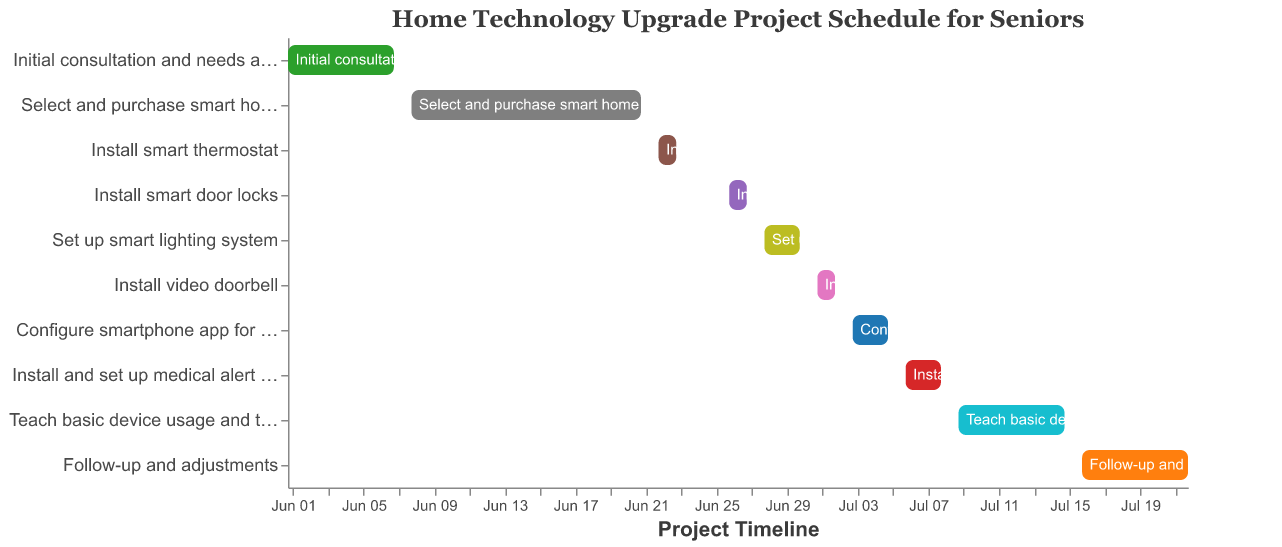What is the title of the Gantt Chart? The title of the chart is usually displayed prominently at the top. In this case, it reads "Home Technology Upgrade Project Schedule for Seniors."
Answer: Home Technology Upgrade Project Schedule for Seniors When does the project to "Install smart door locks" start and end? By looking at the "Install smart door locks" task, you can see the start and end dates mentioned as June 26 and June 27 respectively.
Answer: June 26 to June 27 How many days is the "Initial consultation and needs assessment" scheduled to last? To find the duration, subtract the start date (June 1) from the end date (June 7). The duration is 7 - 1 + 1 (because both start and end days are inclusive), which equals 7 days.
Answer: 7 days Which activities are scheduled to take place immediately after "Configure smartphone app for device control"? Looking at the timeline, the task following the "Configure smartphone app for device control" (ending on July 5), is "Install and set up medical alert system," starting on July 6.
Answer: Install and set up medical alert system Which task takes the longest time to complete, and how long does it take? To determine the longest task, compare the duration of all tasks. "Teach basic device usage and troubleshooting" lasts from July 9 to July 15, which is 7 days, making it the longest.
Answer: Teach basic device usage and troubleshooting, 7 days Are there any tasks scheduled to start and end within the same day? By reviewing each task, the only task that starts and ends on separate days are excluded. Checking the dates, none of the tasks fit this criterion.
Answer: No What are the end dates of "Install smart thermostat" and "Install video doorbell"? Checking the individual tasks, the end date for "Install smart thermostat" is June 23, and for "Install video doorbell" is July 2.
Answer: June 23 and July 2 Between "Follow-up and adjustments" and "Teach basic device usage and troubleshooting", which starts earlier? By comparing the start dates in the chart, "Teach basic device usage and troubleshooting" starts on July 9, while "Follow-up and adjustments" starts on July 16. Hence, the former begins earlier.
Answer: Teach basic device usage and troubleshooting How many tasks are scheduled for June? Count the tasks listed under June. They are 5: "Initial consultation and needs assessment", "Select and purchase smart home devices", "Install smart thermostat", "Install smart door locks", and "Set up smart lighting system".
Answer: 5 tasks 